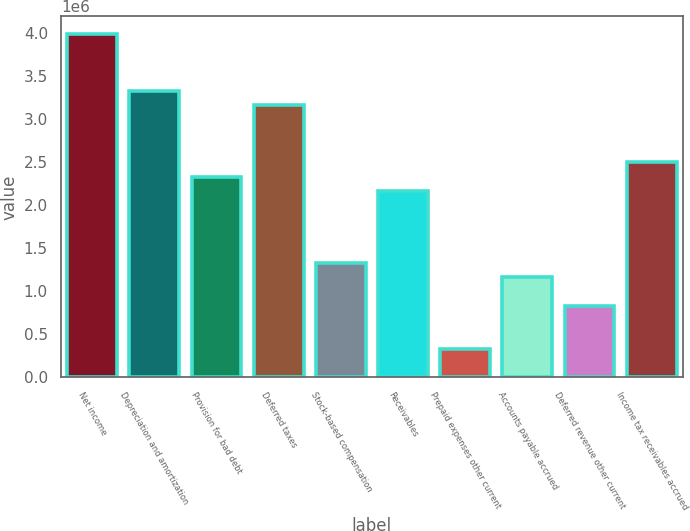Convert chart to OTSL. <chart><loc_0><loc_0><loc_500><loc_500><bar_chart><fcel>Net income<fcel>Depreciation and amortization<fcel>Provision for bad debt<fcel>Deferred taxes<fcel>Stock-based compensation<fcel>Receivables<fcel>Prepaid expenses other current<fcel>Accounts payable accrued<fcel>Deferred revenue other current<fcel>Income tax receivables accrued<nl><fcel>3.99123e+06<fcel>3.32621e+06<fcel>2.32869e+06<fcel>3.15996e+06<fcel>1.33117e+06<fcel>2.16244e+06<fcel>333650<fcel>1.16492e+06<fcel>832410<fcel>2.49495e+06<nl></chart> 